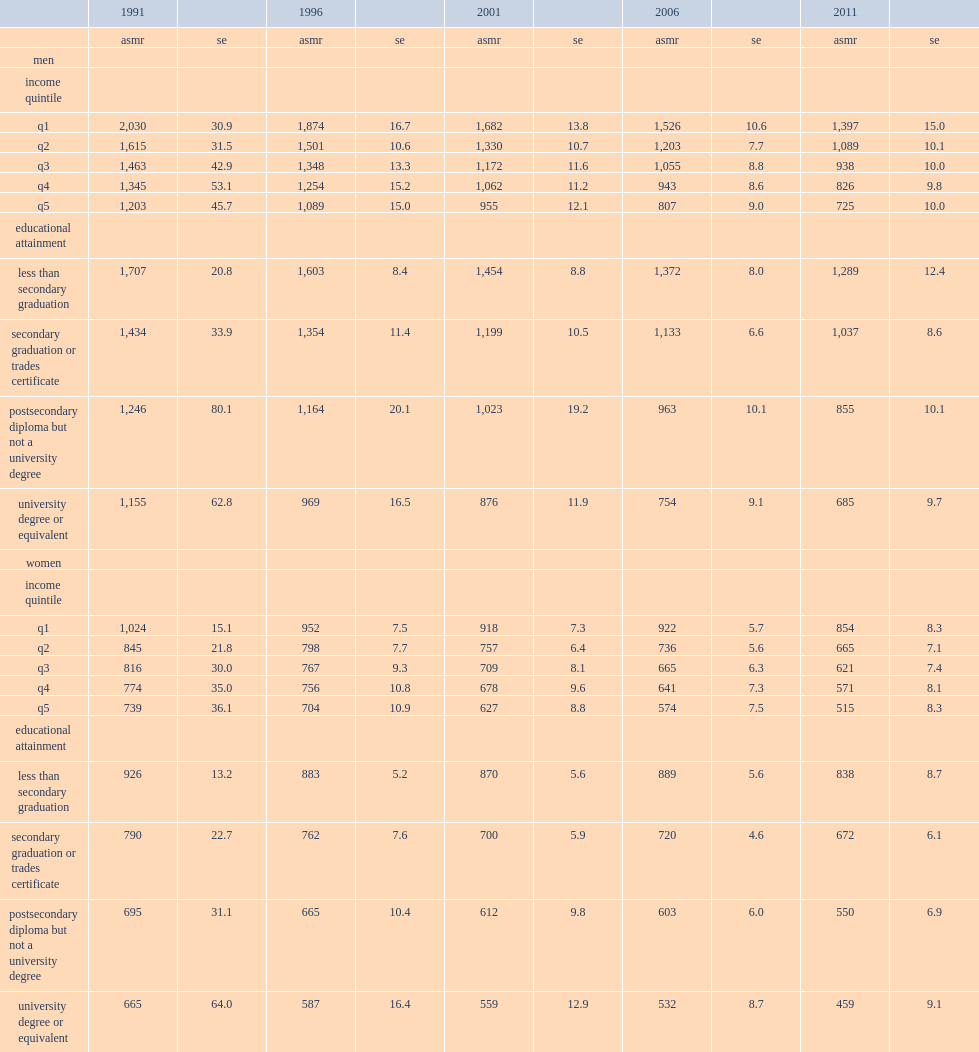Among which income quintile were asmrs highest for men across in 1991? Q1. Among which income quintile were asmrs highest for men across in 1996? Q1. Among which income quintile were asmrs highest for men across in 2001? Q1. Among which income quintile were asmrs highest for men across in 2006? Q1. Among which income quintile were asmrs highest for men across in 2011? Q1. Among which income quintile were asmrs highest for women across in 1991? Q1. Among which income quintile were asmrs highest for women across in 1996? Q1. Among which income quintile were asmrs highest for women across in 2001? Q1. Among which income quintile were asmrs highest for women across in 2006? Q1. Among which income quintile were asmrs highest for women across in 2011? Q1. 